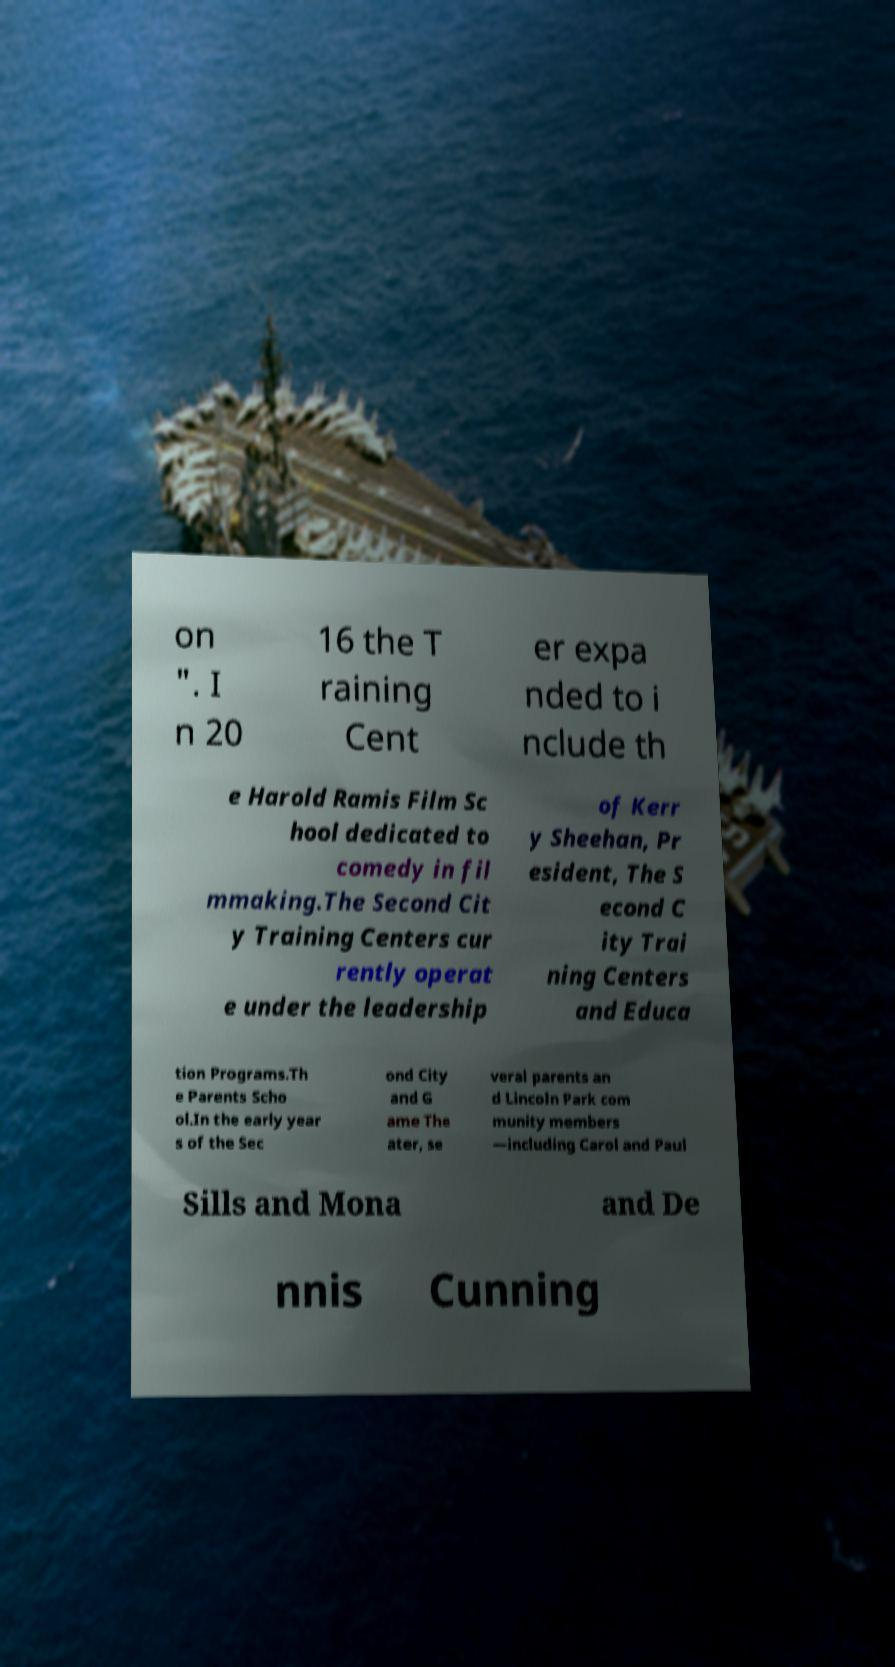For documentation purposes, I need the text within this image transcribed. Could you provide that? on ". I n 20 16 the T raining Cent er expa nded to i nclude th e Harold Ramis Film Sc hool dedicated to comedy in fil mmaking.The Second Cit y Training Centers cur rently operat e under the leadership of Kerr y Sheehan, Pr esident, The S econd C ity Trai ning Centers and Educa tion Programs.Th e Parents Scho ol.In the early year s of the Sec ond City and G ame The ater, se veral parents an d Lincoln Park com munity members —including Carol and Paul Sills and Mona and De nnis Cunning 